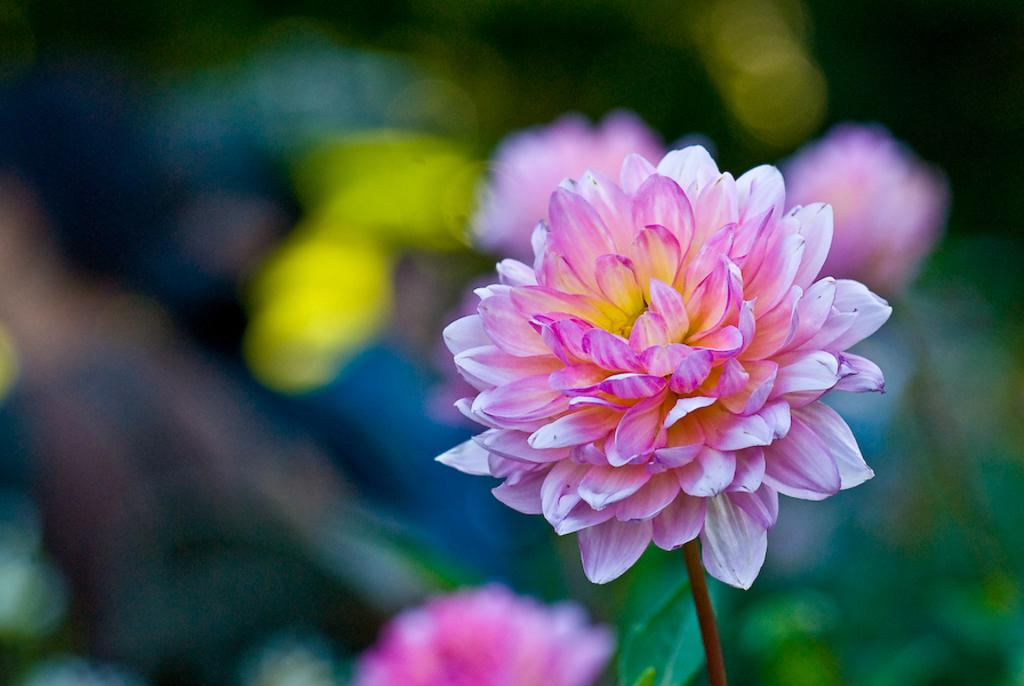What color are the flowers on the plants in the image? The flowers on the plants in the image are pink. How many afterthoughts are present in the image? There is no mention of afterthoughts in the image, as it features pink color flowers on the plants. What type of wire can be seen connecting the flowers in the image? There is no wire present in the image; it only shows pink color flowers on the plants. 